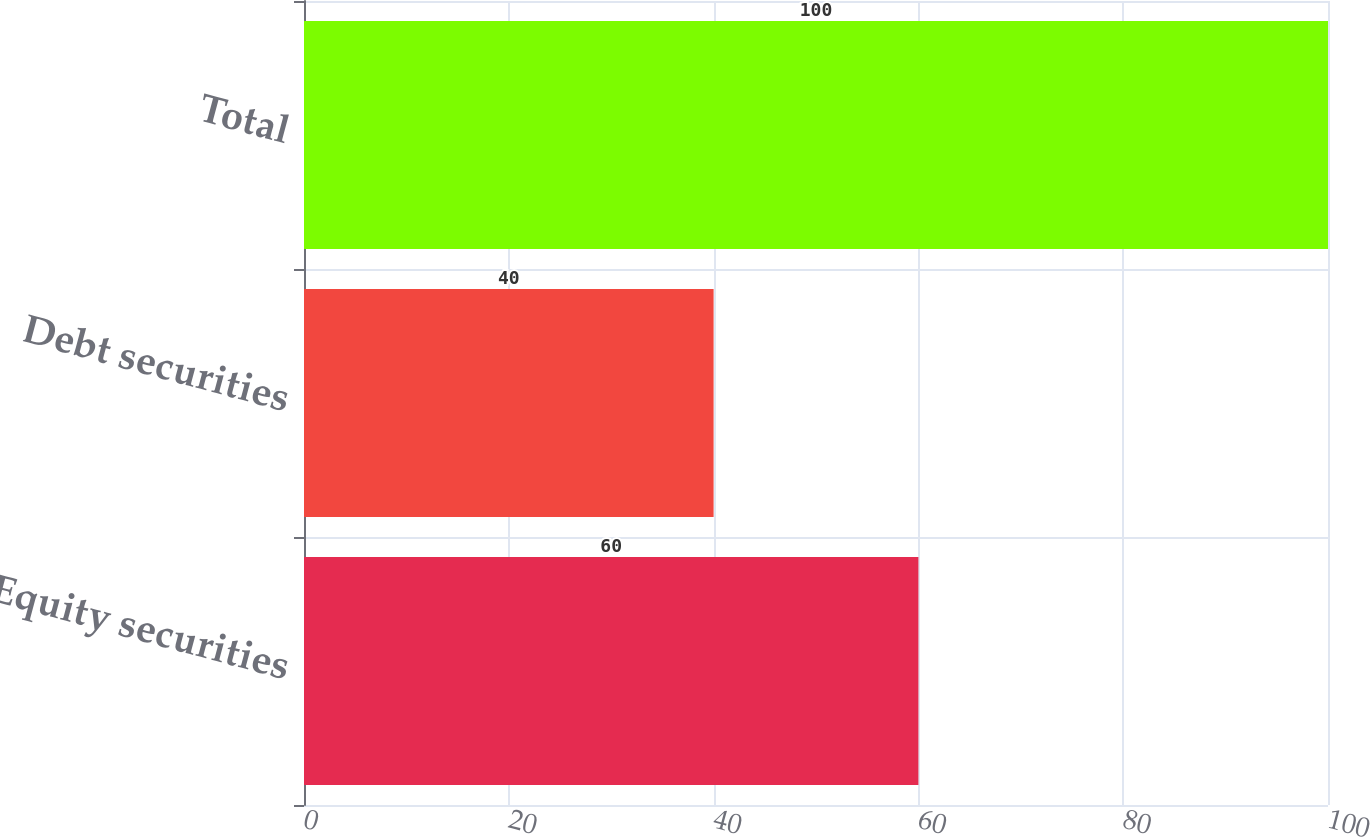Convert chart. <chart><loc_0><loc_0><loc_500><loc_500><bar_chart><fcel>Equity securities<fcel>Debt securities<fcel>Total<nl><fcel>60<fcel>40<fcel>100<nl></chart> 